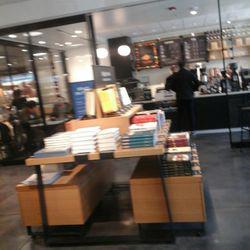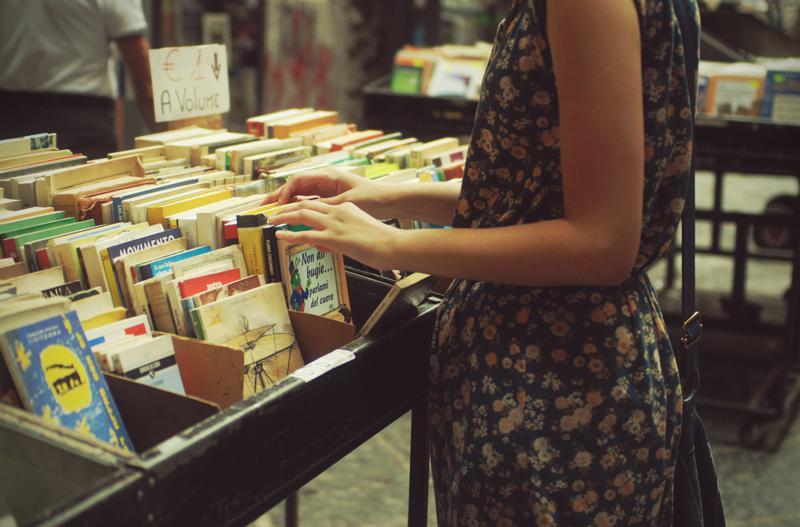The first image is the image on the left, the second image is the image on the right. Analyze the images presented: Is the assertion "In at least one image there is a door and two window at the front of the bookstore." valid? Answer yes or no. No. The first image is the image on the left, the second image is the image on the right. Assess this claim about the two images: "There are human beings visible in at least one image.". Correct or not? Answer yes or no. Yes. 